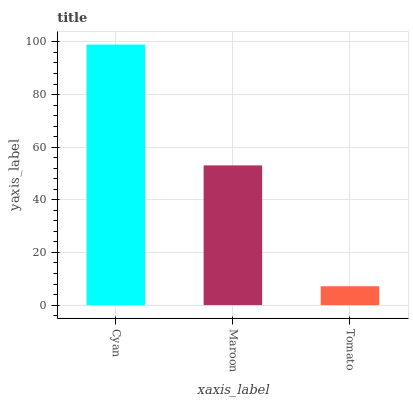Is Tomato the minimum?
Answer yes or no. Yes. Is Cyan the maximum?
Answer yes or no. Yes. Is Maroon the minimum?
Answer yes or no. No. Is Maroon the maximum?
Answer yes or no. No. Is Cyan greater than Maroon?
Answer yes or no. Yes. Is Maroon less than Cyan?
Answer yes or no. Yes. Is Maroon greater than Cyan?
Answer yes or no. No. Is Cyan less than Maroon?
Answer yes or no. No. Is Maroon the high median?
Answer yes or no. Yes. Is Maroon the low median?
Answer yes or no. Yes. Is Tomato the high median?
Answer yes or no. No. Is Tomato the low median?
Answer yes or no. No. 